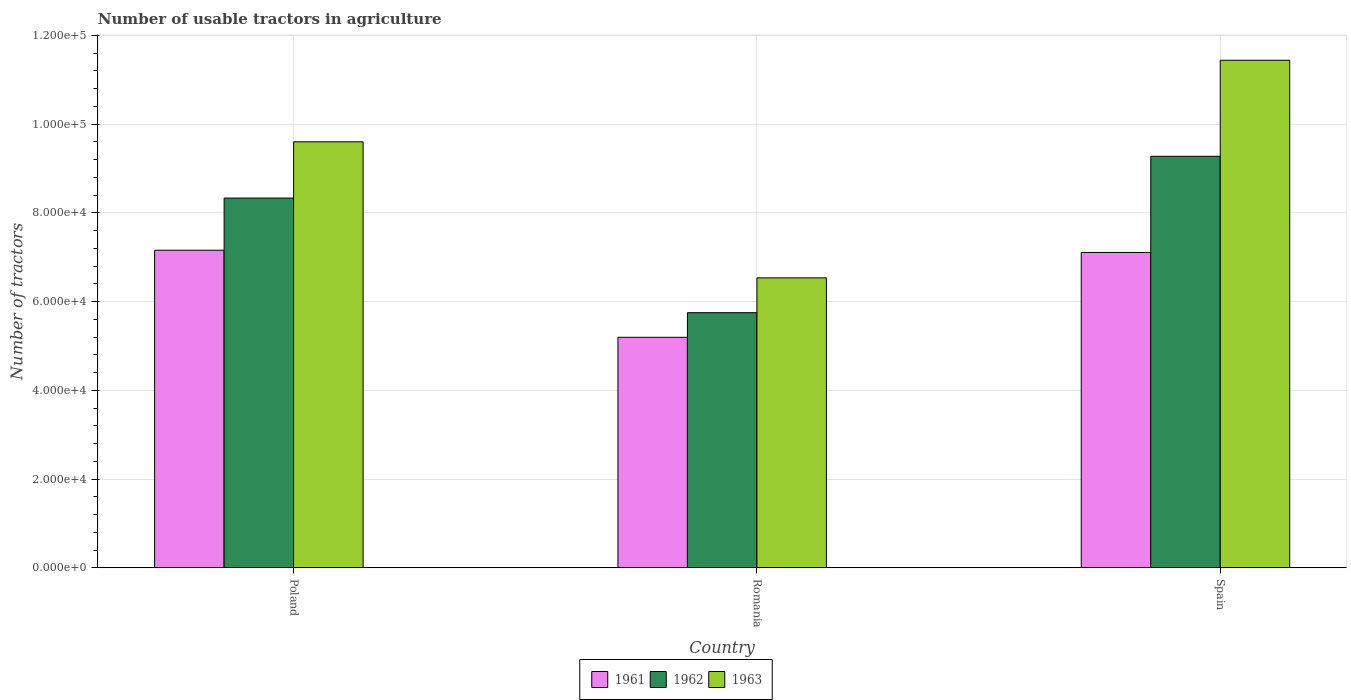Are the number of bars on each tick of the X-axis equal?
Your response must be concise. Yes. How many bars are there on the 3rd tick from the right?
Offer a very short reply. 3. What is the label of the 1st group of bars from the left?
Keep it short and to the point. Poland. In how many cases, is the number of bars for a given country not equal to the number of legend labels?
Ensure brevity in your answer.  0. What is the number of usable tractors in agriculture in 1961 in Poland?
Offer a very short reply. 7.16e+04. Across all countries, what is the maximum number of usable tractors in agriculture in 1961?
Your answer should be compact. 7.16e+04. Across all countries, what is the minimum number of usable tractors in agriculture in 1963?
Provide a short and direct response. 6.54e+04. In which country was the number of usable tractors in agriculture in 1963 maximum?
Offer a terse response. Spain. In which country was the number of usable tractors in agriculture in 1962 minimum?
Your answer should be very brief. Romania. What is the total number of usable tractors in agriculture in 1963 in the graph?
Give a very brief answer. 2.76e+05. What is the difference between the number of usable tractors in agriculture in 1962 in Romania and that in Spain?
Ensure brevity in your answer.  -3.53e+04. What is the difference between the number of usable tractors in agriculture in 1962 in Romania and the number of usable tractors in agriculture in 1963 in Spain?
Your answer should be compact. -5.69e+04. What is the average number of usable tractors in agriculture in 1963 per country?
Offer a very short reply. 9.19e+04. What is the difference between the number of usable tractors in agriculture of/in 1962 and number of usable tractors in agriculture of/in 1963 in Spain?
Provide a short and direct response. -2.17e+04. What is the ratio of the number of usable tractors in agriculture in 1961 in Poland to that in Spain?
Provide a short and direct response. 1.01. Is the number of usable tractors in agriculture in 1963 in Poland less than that in Spain?
Provide a short and direct response. Yes. Is the difference between the number of usable tractors in agriculture in 1962 in Romania and Spain greater than the difference between the number of usable tractors in agriculture in 1963 in Romania and Spain?
Your answer should be compact. Yes. What is the difference between the highest and the second highest number of usable tractors in agriculture in 1961?
Your answer should be very brief. -1.96e+04. What is the difference between the highest and the lowest number of usable tractors in agriculture in 1963?
Make the answer very short. 4.91e+04. What does the 3rd bar from the right in Spain represents?
Provide a short and direct response. 1961. Is it the case that in every country, the sum of the number of usable tractors in agriculture in 1961 and number of usable tractors in agriculture in 1963 is greater than the number of usable tractors in agriculture in 1962?
Offer a terse response. Yes. Are all the bars in the graph horizontal?
Ensure brevity in your answer.  No. How many countries are there in the graph?
Ensure brevity in your answer.  3. Does the graph contain any zero values?
Keep it short and to the point. No. Does the graph contain grids?
Provide a short and direct response. Yes. How are the legend labels stacked?
Your response must be concise. Horizontal. What is the title of the graph?
Provide a succinct answer. Number of usable tractors in agriculture. What is the label or title of the X-axis?
Make the answer very short. Country. What is the label or title of the Y-axis?
Your answer should be very brief. Number of tractors. What is the Number of tractors in 1961 in Poland?
Offer a terse response. 7.16e+04. What is the Number of tractors in 1962 in Poland?
Make the answer very short. 8.33e+04. What is the Number of tractors of 1963 in Poland?
Ensure brevity in your answer.  9.60e+04. What is the Number of tractors in 1961 in Romania?
Your answer should be compact. 5.20e+04. What is the Number of tractors of 1962 in Romania?
Ensure brevity in your answer.  5.75e+04. What is the Number of tractors in 1963 in Romania?
Give a very brief answer. 6.54e+04. What is the Number of tractors of 1961 in Spain?
Give a very brief answer. 7.11e+04. What is the Number of tractors of 1962 in Spain?
Ensure brevity in your answer.  9.28e+04. What is the Number of tractors of 1963 in Spain?
Offer a very short reply. 1.14e+05. Across all countries, what is the maximum Number of tractors of 1961?
Your response must be concise. 7.16e+04. Across all countries, what is the maximum Number of tractors in 1962?
Make the answer very short. 9.28e+04. Across all countries, what is the maximum Number of tractors of 1963?
Offer a very short reply. 1.14e+05. Across all countries, what is the minimum Number of tractors in 1961?
Your response must be concise. 5.20e+04. Across all countries, what is the minimum Number of tractors of 1962?
Your answer should be compact. 5.75e+04. Across all countries, what is the minimum Number of tractors of 1963?
Your answer should be compact. 6.54e+04. What is the total Number of tractors in 1961 in the graph?
Provide a short and direct response. 1.95e+05. What is the total Number of tractors of 1962 in the graph?
Give a very brief answer. 2.34e+05. What is the total Number of tractors of 1963 in the graph?
Ensure brevity in your answer.  2.76e+05. What is the difference between the Number of tractors in 1961 in Poland and that in Romania?
Offer a terse response. 1.96e+04. What is the difference between the Number of tractors in 1962 in Poland and that in Romania?
Make the answer very short. 2.58e+04. What is the difference between the Number of tractors in 1963 in Poland and that in Romania?
Provide a succinct answer. 3.07e+04. What is the difference between the Number of tractors of 1962 in Poland and that in Spain?
Offer a terse response. -9414. What is the difference between the Number of tractors of 1963 in Poland and that in Spain?
Ensure brevity in your answer.  -1.84e+04. What is the difference between the Number of tractors of 1961 in Romania and that in Spain?
Your response must be concise. -1.91e+04. What is the difference between the Number of tractors of 1962 in Romania and that in Spain?
Give a very brief answer. -3.53e+04. What is the difference between the Number of tractors in 1963 in Romania and that in Spain?
Your answer should be very brief. -4.91e+04. What is the difference between the Number of tractors of 1961 in Poland and the Number of tractors of 1962 in Romania?
Make the answer very short. 1.41e+04. What is the difference between the Number of tractors of 1961 in Poland and the Number of tractors of 1963 in Romania?
Your response must be concise. 6226. What is the difference between the Number of tractors of 1962 in Poland and the Number of tractors of 1963 in Romania?
Make the answer very short. 1.80e+04. What is the difference between the Number of tractors of 1961 in Poland and the Number of tractors of 1962 in Spain?
Keep it short and to the point. -2.12e+04. What is the difference between the Number of tractors in 1961 in Poland and the Number of tractors in 1963 in Spain?
Offer a very short reply. -4.28e+04. What is the difference between the Number of tractors in 1962 in Poland and the Number of tractors in 1963 in Spain?
Your response must be concise. -3.11e+04. What is the difference between the Number of tractors of 1961 in Romania and the Number of tractors of 1962 in Spain?
Ensure brevity in your answer.  -4.08e+04. What is the difference between the Number of tractors of 1961 in Romania and the Number of tractors of 1963 in Spain?
Your response must be concise. -6.25e+04. What is the difference between the Number of tractors of 1962 in Romania and the Number of tractors of 1963 in Spain?
Offer a very short reply. -5.69e+04. What is the average Number of tractors in 1961 per country?
Make the answer very short. 6.49e+04. What is the average Number of tractors of 1962 per country?
Provide a succinct answer. 7.79e+04. What is the average Number of tractors in 1963 per country?
Keep it short and to the point. 9.19e+04. What is the difference between the Number of tractors of 1961 and Number of tractors of 1962 in Poland?
Offer a very short reply. -1.18e+04. What is the difference between the Number of tractors of 1961 and Number of tractors of 1963 in Poland?
Make the answer very short. -2.44e+04. What is the difference between the Number of tractors of 1962 and Number of tractors of 1963 in Poland?
Your response must be concise. -1.27e+04. What is the difference between the Number of tractors in 1961 and Number of tractors in 1962 in Romania?
Ensure brevity in your answer.  -5548. What is the difference between the Number of tractors in 1961 and Number of tractors in 1963 in Romania?
Your response must be concise. -1.34e+04. What is the difference between the Number of tractors of 1962 and Number of tractors of 1963 in Romania?
Make the answer very short. -7851. What is the difference between the Number of tractors in 1961 and Number of tractors in 1962 in Spain?
Your response must be concise. -2.17e+04. What is the difference between the Number of tractors in 1961 and Number of tractors in 1963 in Spain?
Offer a very short reply. -4.33e+04. What is the difference between the Number of tractors in 1962 and Number of tractors in 1963 in Spain?
Your response must be concise. -2.17e+04. What is the ratio of the Number of tractors of 1961 in Poland to that in Romania?
Your answer should be compact. 1.38. What is the ratio of the Number of tractors of 1962 in Poland to that in Romania?
Provide a succinct answer. 1.45. What is the ratio of the Number of tractors in 1963 in Poland to that in Romania?
Ensure brevity in your answer.  1.47. What is the ratio of the Number of tractors of 1962 in Poland to that in Spain?
Give a very brief answer. 0.9. What is the ratio of the Number of tractors of 1963 in Poland to that in Spain?
Provide a short and direct response. 0.84. What is the ratio of the Number of tractors in 1961 in Romania to that in Spain?
Your answer should be very brief. 0.73. What is the ratio of the Number of tractors of 1962 in Romania to that in Spain?
Offer a very short reply. 0.62. What is the ratio of the Number of tractors in 1963 in Romania to that in Spain?
Offer a terse response. 0.57. What is the difference between the highest and the second highest Number of tractors of 1961?
Your answer should be compact. 500. What is the difference between the highest and the second highest Number of tractors of 1962?
Offer a very short reply. 9414. What is the difference between the highest and the second highest Number of tractors of 1963?
Give a very brief answer. 1.84e+04. What is the difference between the highest and the lowest Number of tractors of 1961?
Make the answer very short. 1.96e+04. What is the difference between the highest and the lowest Number of tractors in 1962?
Keep it short and to the point. 3.53e+04. What is the difference between the highest and the lowest Number of tractors of 1963?
Give a very brief answer. 4.91e+04. 